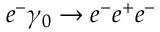Convert formula to latex. <formula><loc_0><loc_0><loc_500><loc_500>e ^ { - } \gamma _ { 0 } \rightarrow e ^ { - } e ^ { + } e ^ { - }</formula> 